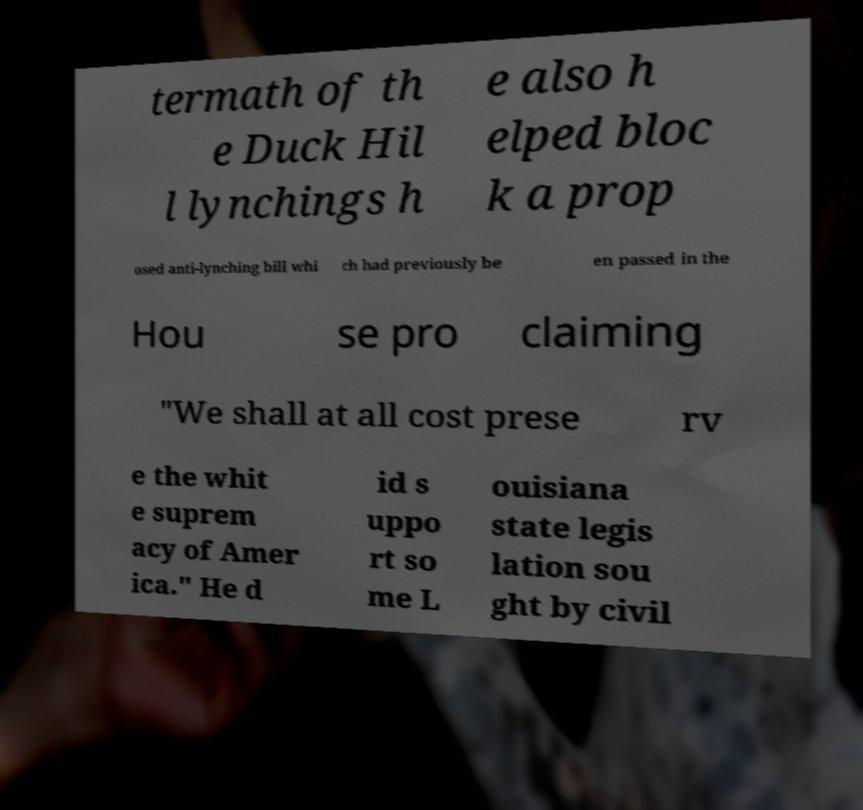Please identify and transcribe the text found in this image. termath of th e Duck Hil l lynchings h e also h elped bloc k a prop osed anti-lynching bill whi ch had previously be en passed in the Hou se pro claiming "We shall at all cost prese rv e the whit e suprem acy of Amer ica." He d id s uppo rt so me L ouisiana state legis lation sou ght by civil 